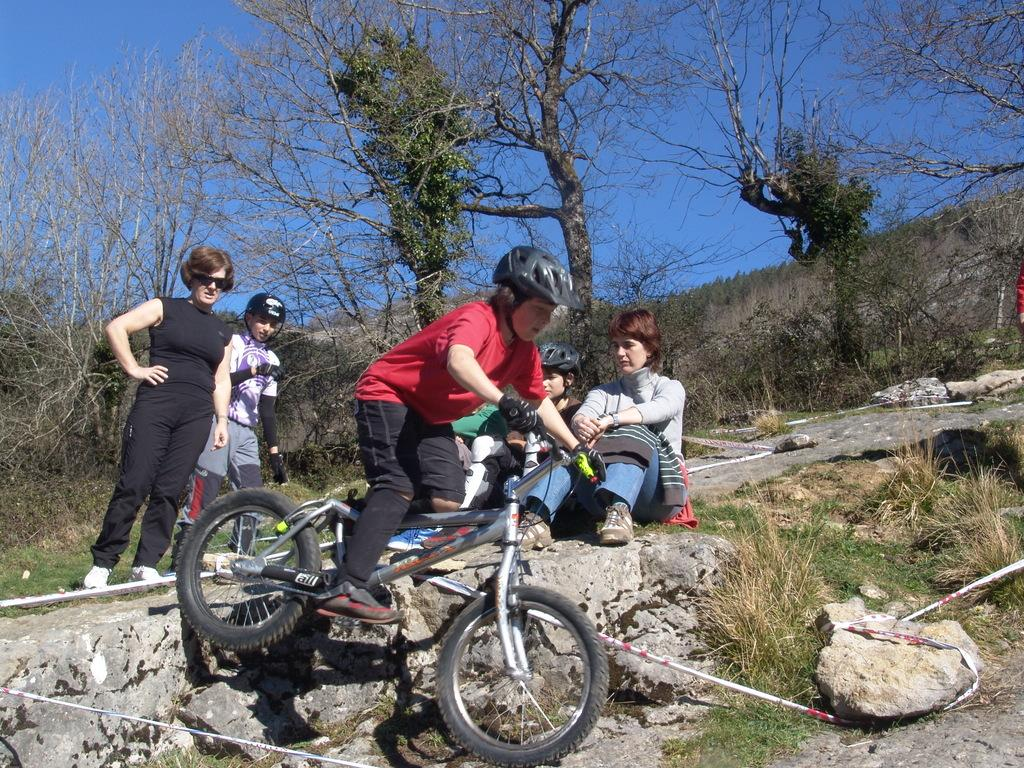What is the boy doing in the image? The boy is riding a bicycle in the image. How many people are seated in the image? There are two people seated in the image. How many people are standing in the image? There are two people standing on the side in the image. What type of vegetation can be seen in the image? There are trees visible in the image. What color is the sky in the image? The sky is blue in the image. What type of star is visible in the image? There is no star visible in the image; it only shows a boy riding a bicycle, people seated and standing, trees, and a blue sky. What type of credit can be seen in the image? There is no credit visible in the image; it is a photograph or illustration and does not contain any financial information. 